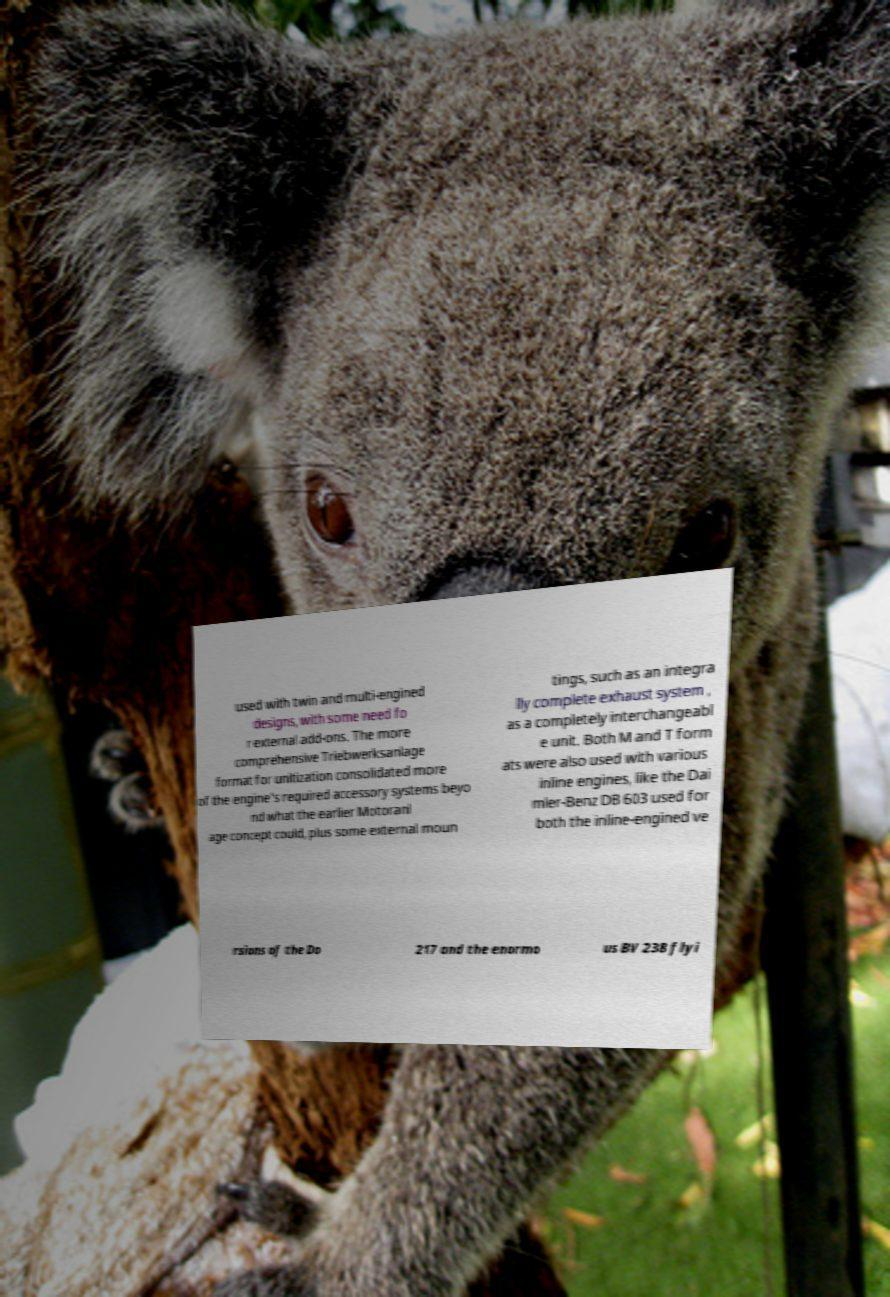Please read and relay the text visible in this image. What does it say? used with twin and multi-engined designs, with some need fo r external add-ons. The more comprehensive Triebwerksanlage format for unitization consolidated more of the engine's required accessory systems beyo nd what the earlier Motoranl age concept could, plus some external moun tings, such as an integra lly complete exhaust system , as a completely interchangeabl e unit. Both M and T form ats were also used with various inline engines, like the Dai mler-Benz DB 603 used for both the inline-engined ve rsions of the Do 217 and the enormo us BV 238 flyi 